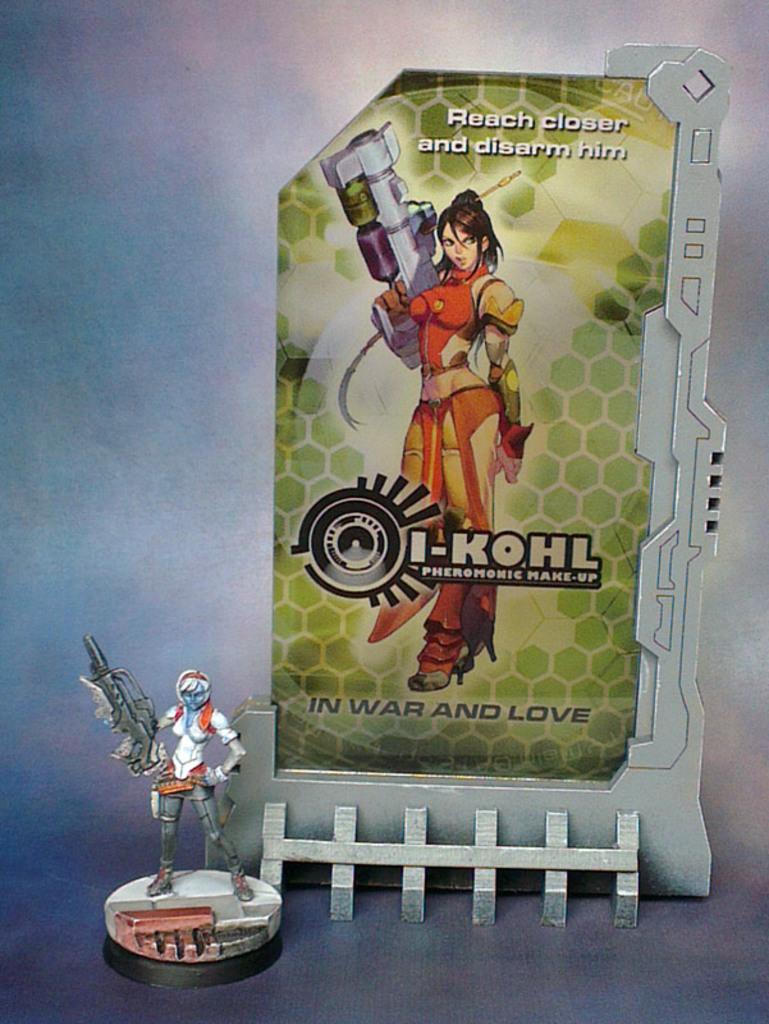Could you give a brief overview of what you see in this image? In the image I can see a cartoon image of a woman and toy. At the top of the image I can see some written text. 